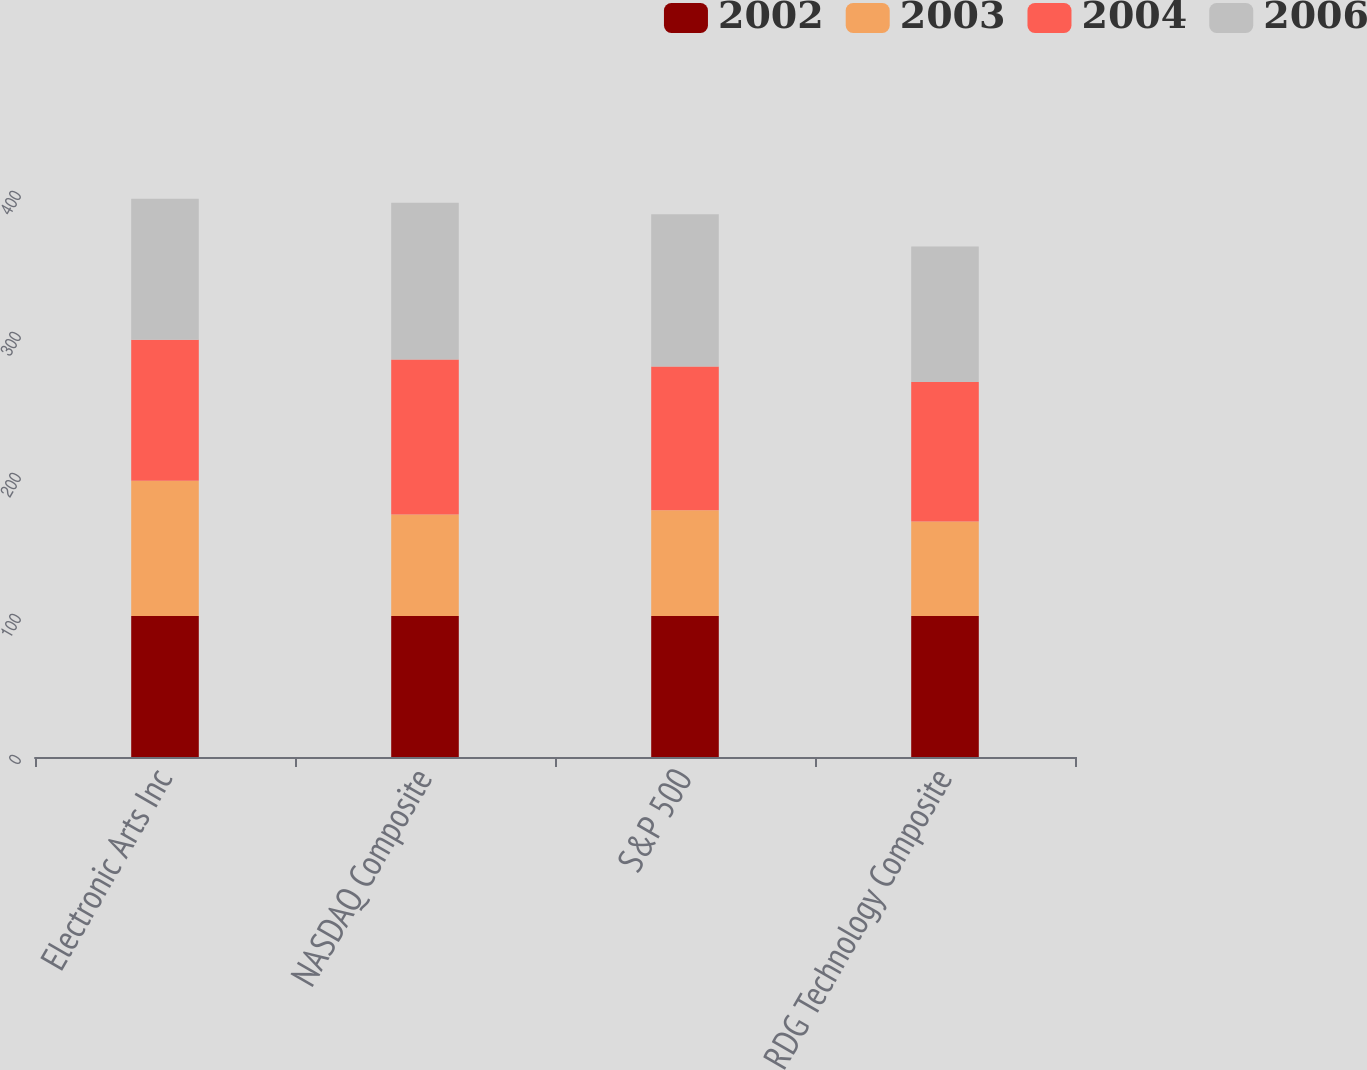Convert chart to OTSL. <chart><loc_0><loc_0><loc_500><loc_500><stacked_bar_chart><ecel><fcel>Electronic Arts Inc<fcel>NASDAQ Composite<fcel>S&P 500<fcel>RDG Technology Composite<nl><fcel>2002<fcel>100<fcel>100<fcel>100<fcel>100<nl><fcel>2003<fcel>96<fcel>72<fcel>75<fcel>67<nl><fcel>2004<fcel>100<fcel>110<fcel>102<fcel>99<nl><fcel>2006<fcel>100<fcel>111<fcel>108<fcel>96<nl></chart> 